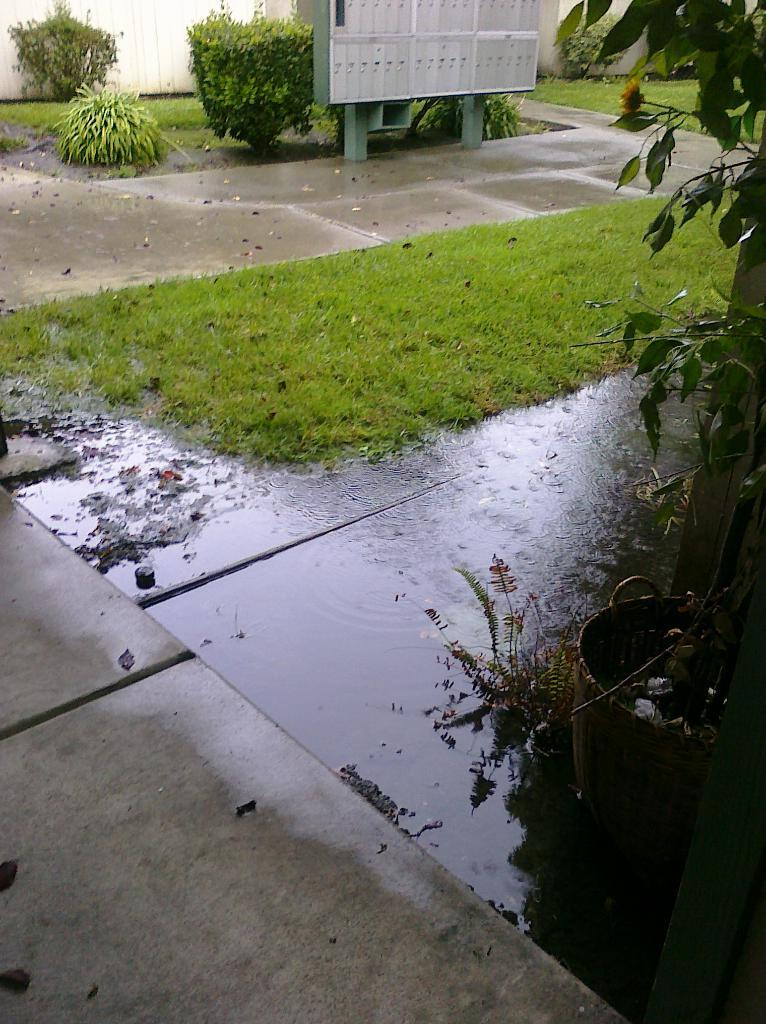What can be seen on the floor in the image? There is water stagnation on the floor in the image. What type of vegetation is present near the water? There is grass on the surface near the water. Are there any other plants visible in the image? Yes, there are plants in the image. What other object can be seen in the image? There is an electric board in the image. How many stitches are visible on the giraffe in the image? There is no giraffe present in the image, and therefore no stitches can be observed. What type of webs can be seen in the image? There is no mention of spiders or webs in the image, so it cannot be determined if any are present. 